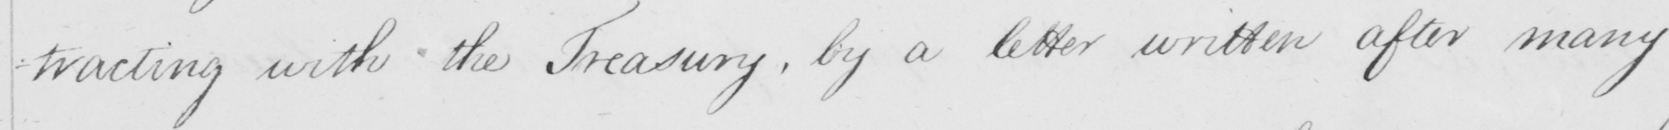What does this handwritten line say? -tracting with the Treasury , by a letter written after many 